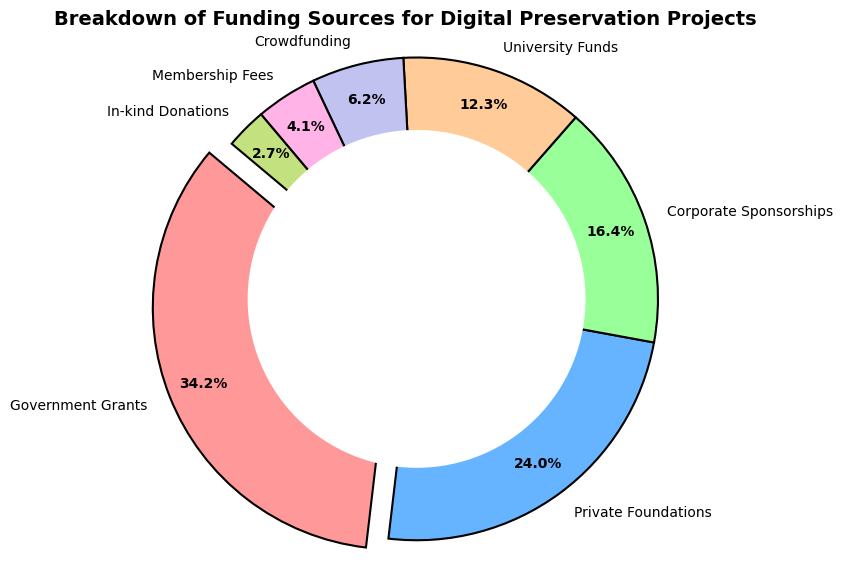What is the largest funding source and what percentage does it contribute? The largest funding source is the Government Grants. By observing the ring chart, we can see that the exploded slice represents Government Grants, and the percentage shown is 40.3%.
Answer: Government Grants, 40.3% Which two funding sources together contribute the highest percentage? By observing the chart, Government Grants is the highest at 40.3% and Private Foundations is the next highest at 28.2%. Together, they contribute 40.3% + 28.2% = 68.5%.
Answer: Government Grants and Private Foundations, 68.5% What is the combined percentage contribution of the three smallest funding sources? The three smallest funding sources by visual observation are In-kind Donations, Membership Fees, and Crowdfunding. Their percentages are 3.2%, 4.8%, and 7.3% respectively. Combining them, 3.2% + 4.8% + 7.3% = 15.3%.
Answer: 15.3% How does the percentage contribution of University Funds compare with that of Corporate Sponsorships? University Funds contribute 14.5%, whereas Corporate Sponsorships contribute 19.4%. Therefore, University Funds contribute less than Corporate Sponsorships by 19.4% - 14.5% = 4.9%.
Answer: University Funds contribute 4.9% less than Corporate Sponsorships Which funding source contributes the smallest amount and what is that amount? By visual observation, the smallest slice belongs to In-kind Donations, contributing $20,000.
Answer: In-kind Donations, $20,000 What is the color associated with Private Foundations, and what percentage do they contribute? Private Foundations have a blue color associated with them in the ring chart and they contribute 28.2%.
Answer: Blue, 28.2% What are the total contributions of non-governmental funding sources? To find the total, sum the amounts of all sources except Government Grants: $175,000 (Private Foundations) + $120,000 (Corporate Sponsorships) + $90,000 (University Funds) + $45,000 (Crowdfunding) + $30,000 (Membership Fees) + $20,000 (In-kind Donations) = $480,000.
Answer: $480,000 How much more does Government Grants contribute compared to Corporate Sponsorships? Government Grants contribute $250,000 while Corporate Sponsorships contribute $120,000. The difference is $250,000 - $120,000 = $130,000.
Answer: $130,000 